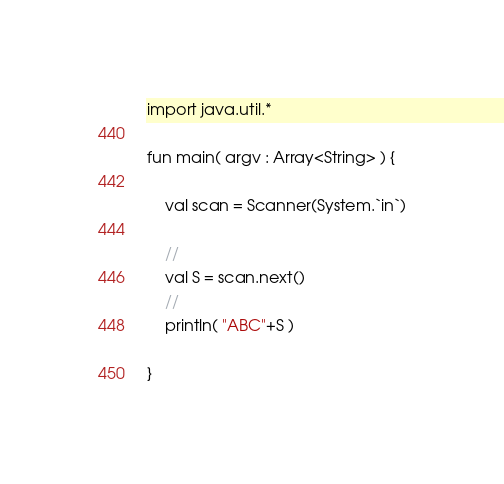<code> <loc_0><loc_0><loc_500><loc_500><_Kotlin_>
import java.util.*

fun main( argv : Array<String> ) {
    
    val scan = Scanner(System.`in`)
    
    //
    val S = scan.next()
    //
    println( "ABC"+S )

}

</code> 